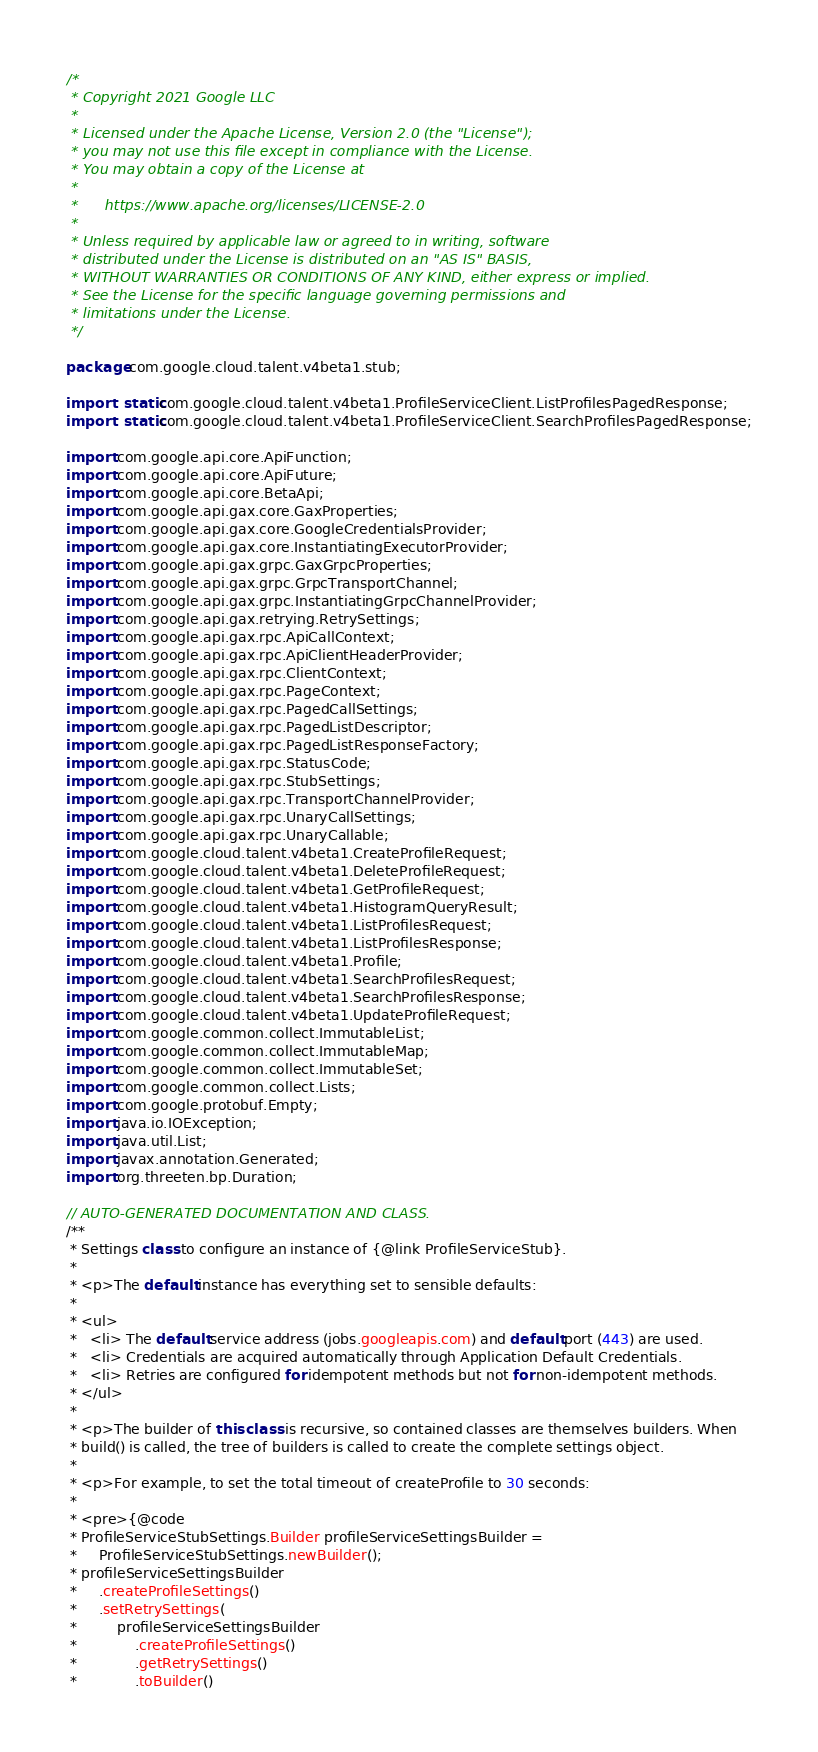Convert code to text. <code><loc_0><loc_0><loc_500><loc_500><_Java_>/*
 * Copyright 2021 Google LLC
 *
 * Licensed under the Apache License, Version 2.0 (the "License");
 * you may not use this file except in compliance with the License.
 * You may obtain a copy of the License at
 *
 *      https://www.apache.org/licenses/LICENSE-2.0
 *
 * Unless required by applicable law or agreed to in writing, software
 * distributed under the License is distributed on an "AS IS" BASIS,
 * WITHOUT WARRANTIES OR CONDITIONS OF ANY KIND, either express or implied.
 * See the License for the specific language governing permissions and
 * limitations under the License.
 */

package com.google.cloud.talent.v4beta1.stub;

import static com.google.cloud.talent.v4beta1.ProfileServiceClient.ListProfilesPagedResponse;
import static com.google.cloud.talent.v4beta1.ProfileServiceClient.SearchProfilesPagedResponse;

import com.google.api.core.ApiFunction;
import com.google.api.core.ApiFuture;
import com.google.api.core.BetaApi;
import com.google.api.gax.core.GaxProperties;
import com.google.api.gax.core.GoogleCredentialsProvider;
import com.google.api.gax.core.InstantiatingExecutorProvider;
import com.google.api.gax.grpc.GaxGrpcProperties;
import com.google.api.gax.grpc.GrpcTransportChannel;
import com.google.api.gax.grpc.InstantiatingGrpcChannelProvider;
import com.google.api.gax.retrying.RetrySettings;
import com.google.api.gax.rpc.ApiCallContext;
import com.google.api.gax.rpc.ApiClientHeaderProvider;
import com.google.api.gax.rpc.ClientContext;
import com.google.api.gax.rpc.PageContext;
import com.google.api.gax.rpc.PagedCallSettings;
import com.google.api.gax.rpc.PagedListDescriptor;
import com.google.api.gax.rpc.PagedListResponseFactory;
import com.google.api.gax.rpc.StatusCode;
import com.google.api.gax.rpc.StubSettings;
import com.google.api.gax.rpc.TransportChannelProvider;
import com.google.api.gax.rpc.UnaryCallSettings;
import com.google.api.gax.rpc.UnaryCallable;
import com.google.cloud.talent.v4beta1.CreateProfileRequest;
import com.google.cloud.talent.v4beta1.DeleteProfileRequest;
import com.google.cloud.talent.v4beta1.GetProfileRequest;
import com.google.cloud.talent.v4beta1.HistogramQueryResult;
import com.google.cloud.talent.v4beta1.ListProfilesRequest;
import com.google.cloud.talent.v4beta1.ListProfilesResponse;
import com.google.cloud.talent.v4beta1.Profile;
import com.google.cloud.talent.v4beta1.SearchProfilesRequest;
import com.google.cloud.talent.v4beta1.SearchProfilesResponse;
import com.google.cloud.talent.v4beta1.UpdateProfileRequest;
import com.google.common.collect.ImmutableList;
import com.google.common.collect.ImmutableMap;
import com.google.common.collect.ImmutableSet;
import com.google.common.collect.Lists;
import com.google.protobuf.Empty;
import java.io.IOException;
import java.util.List;
import javax.annotation.Generated;
import org.threeten.bp.Duration;

// AUTO-GENERATED DOCUMENTATION AND CLASS.
/**
 * Settings class to configure an instance of {@link ProfileServiceStub}.
 *
 * <p>The default instance has everything set to sensible defaults:
 *
 * <ul>
 *   <li> The default service address (jobs.googleapis.com) and default port (443) are used.
 *   <li> Credentials are acquired automatically through Application Default Credentials.
 *   <li> Retries are configured for idempotent methods but not for non-idempotent methods.
 * </ul>
 *
 * <p>The builder of this class is recursive, so contained classes are themselves builders. When
 * build() is called, the tree of builders is called to create the complete settings object.
 *
 * <p>For example, to set the total timeout of createProfile to 30 seconds:
 *
 * <pre>{@code
 * ProfileServiceStubSettings.Builder profileServiceSettingsBuilder =
 *     ProfileServiceStubSettings.newBuilder();
 * profileServiceSettingsBuilder
 *     .createProfileSettings()
 *     .setRetrySettings(
 *         profileServiceSettingsBuilder
 *             .createProfileSettings()
 *             .getRetrySettings()
 *             .toBuilder()</code> 